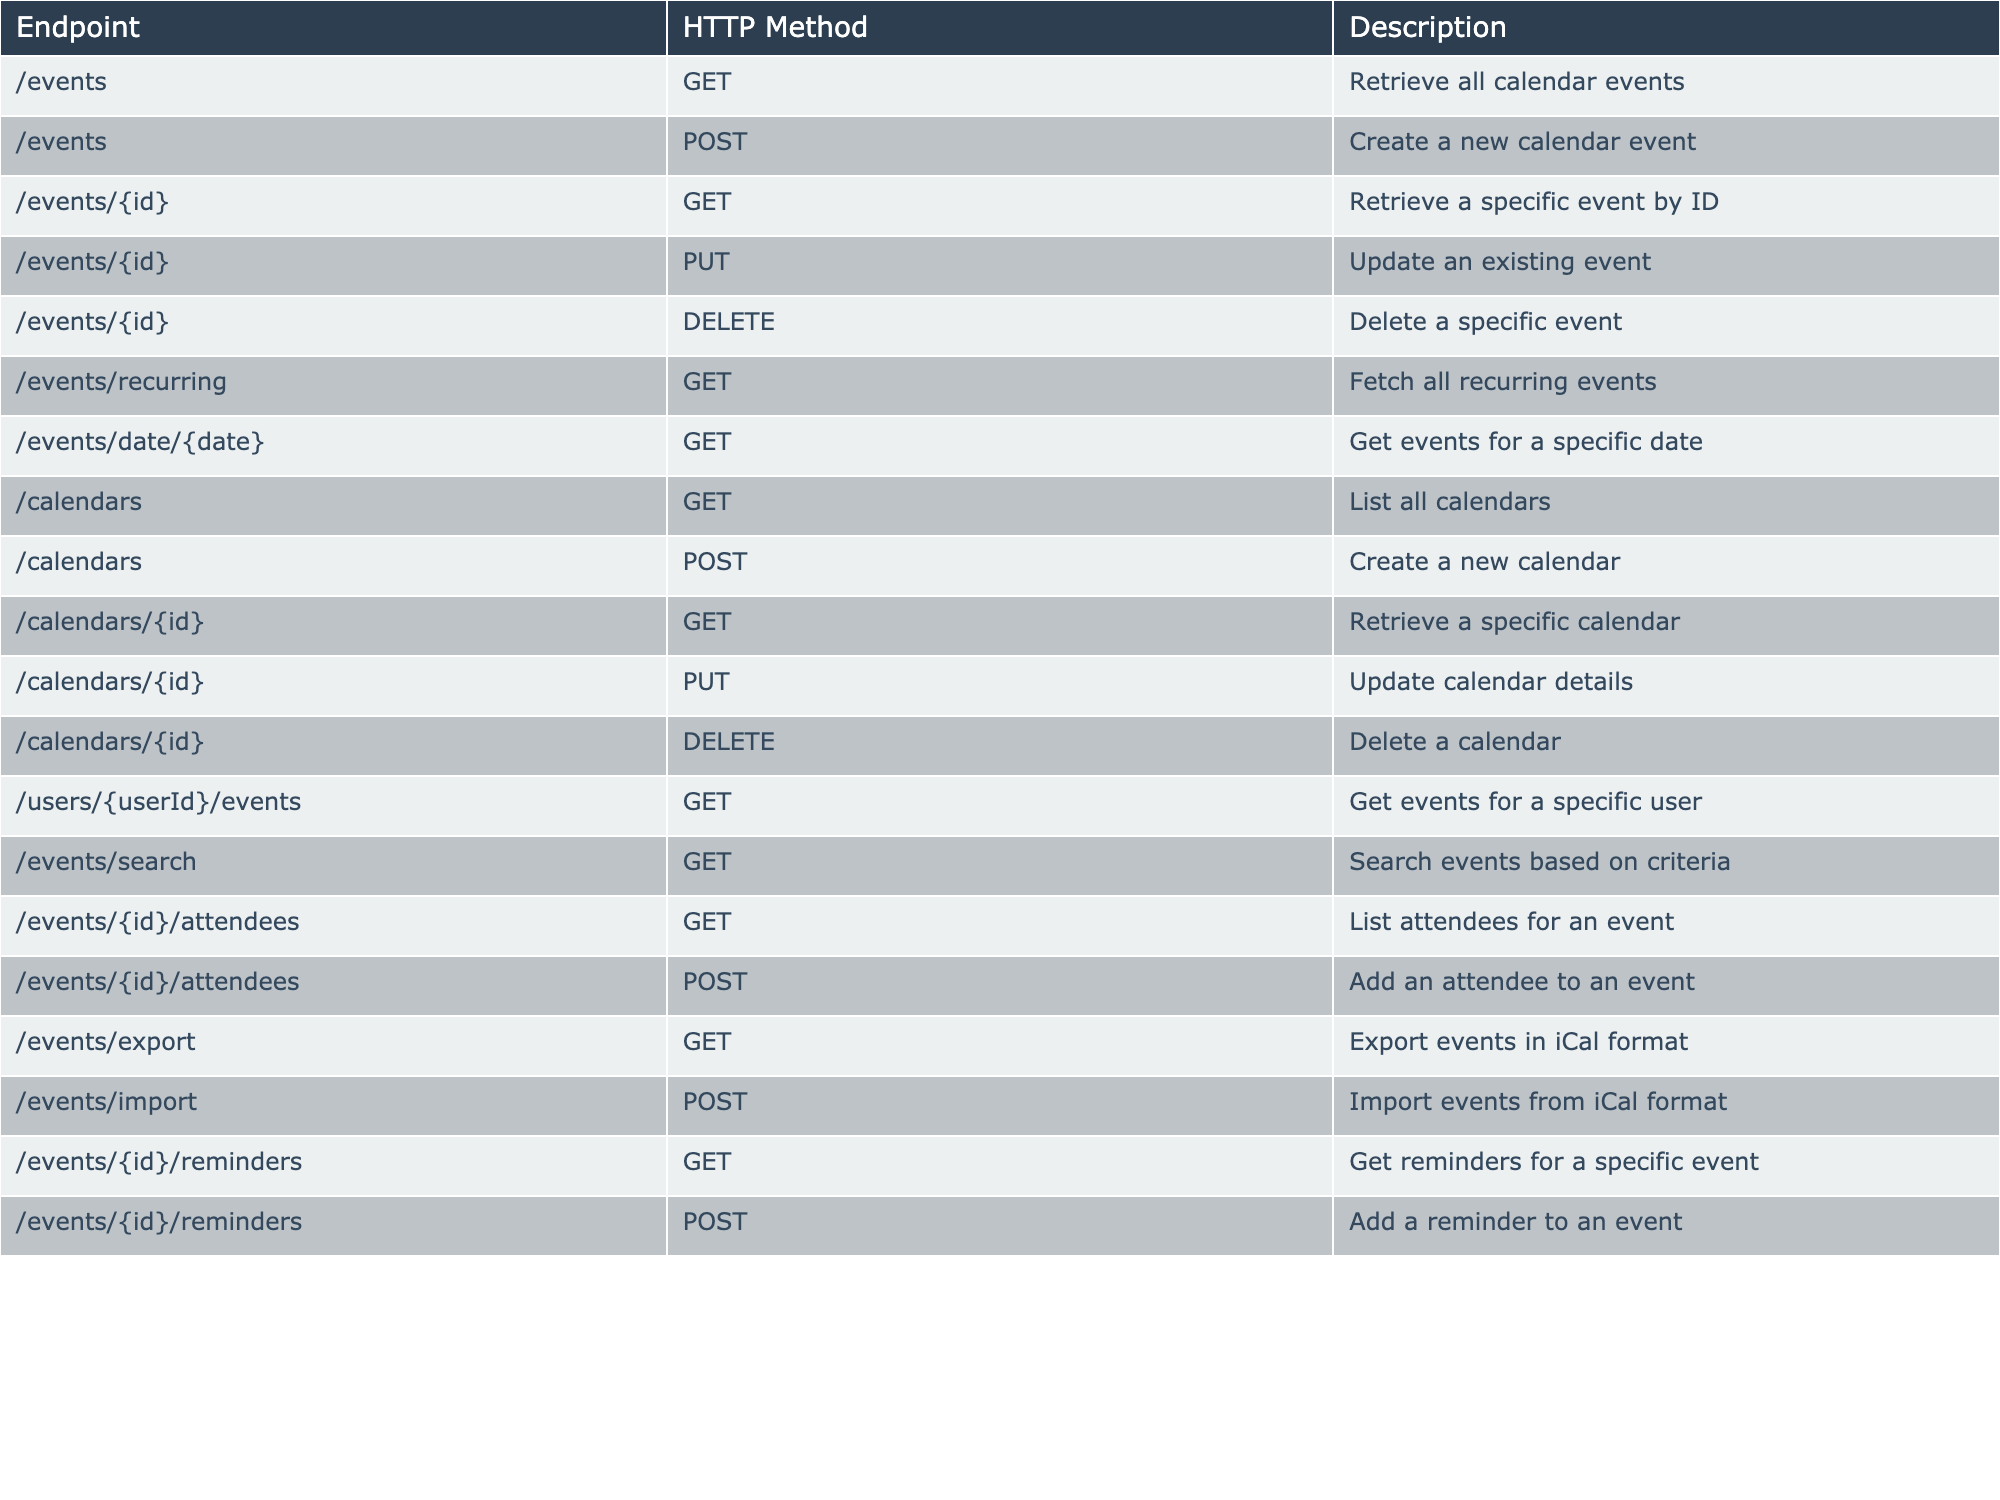What HTTP method is used to create a new calendar event? The table indicates that the POST method is associated with the /events endpoint for creating new calendar events.
Answer: POST How many total HTTP methods are listed for the /calendars endpoint? The /calendars endpoint includes three HTTP methods: GET, POST, and PUT, which gives us a total of three methods.
Answer: 3 Is there a specific endpoint for exporting events? The table shows that there is an /events/export endpoint, which confirms that there is a specific endpoint for exporting events.
Answer: Yes What HTTP methods are used for retrieving events? The table lists the GET method for these endpoints: /events, /events/{id}, /events/recurring, /events/date/{date}, and /events/search, making a total of five GET methods for retrieving events.
Answer: 5 How many endpoints can be used to modify an existing calendar? The /calendars/{id} endpoint has one PUT method for updating calendar details and a DELETE method for deleting a calendar, giving a total of two methods to modify calendars.
Answer: 2 Is it possible to import events from an iCal format? The table confirms that there is a POST method at the /events/import endpoint, indicating that it is possible to import events from iCal format.
Answer: Yes How many total endpoints are dedicated to events compared to calendars? There are 10 endpoints related to events and 6 dedicated to calendars. The difference in the number of endpoints is 10 - 6 = 4.
Answer: 4 What is the purpose of the /events/{id}/attendees endpoint? The table lists this endpoint with both GET and POST methods, indicating its purpose is to list attendees for a specific event and to add an attendee to that event.
Answer: List and add attendees Which endpoint would you use to get events for a specific user? The /users/{userId}/events endpoint has a GET method dedicated specifically for retrieving events associated with a particular user.
Answer: /users/{userId}/events Are all HTTP methods suitable for every endpoint listed? By reviewing the table, we can see that different endpoints have different HTTP methods assigned to them, showing that not all methods are suitable for every endpoint.
Answer: No 